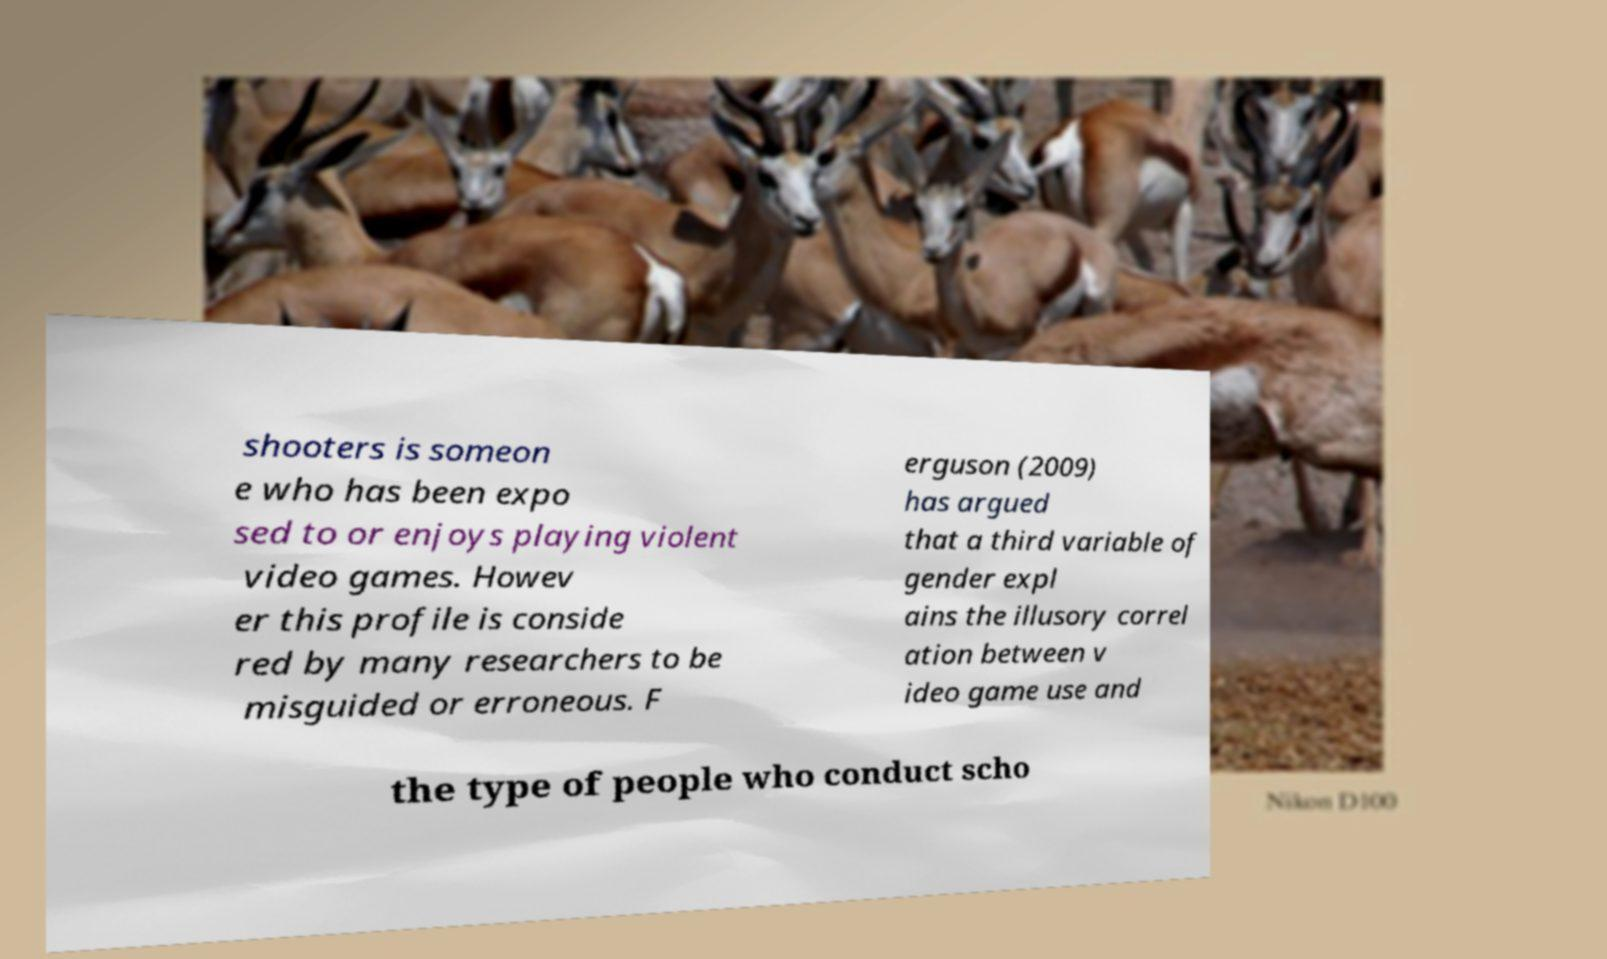Please read and relay the text visible in this image. What does it say? shooters is someon e who has been expo sed to or enjoys playing violent video games. Howev er this profile is conside red by many researchers to be misguided or erroneous. F erguson (2009) has argued that a third variable of gender expl ains the illusory correl ation between v ideo game use and the type of people who conduct scho 